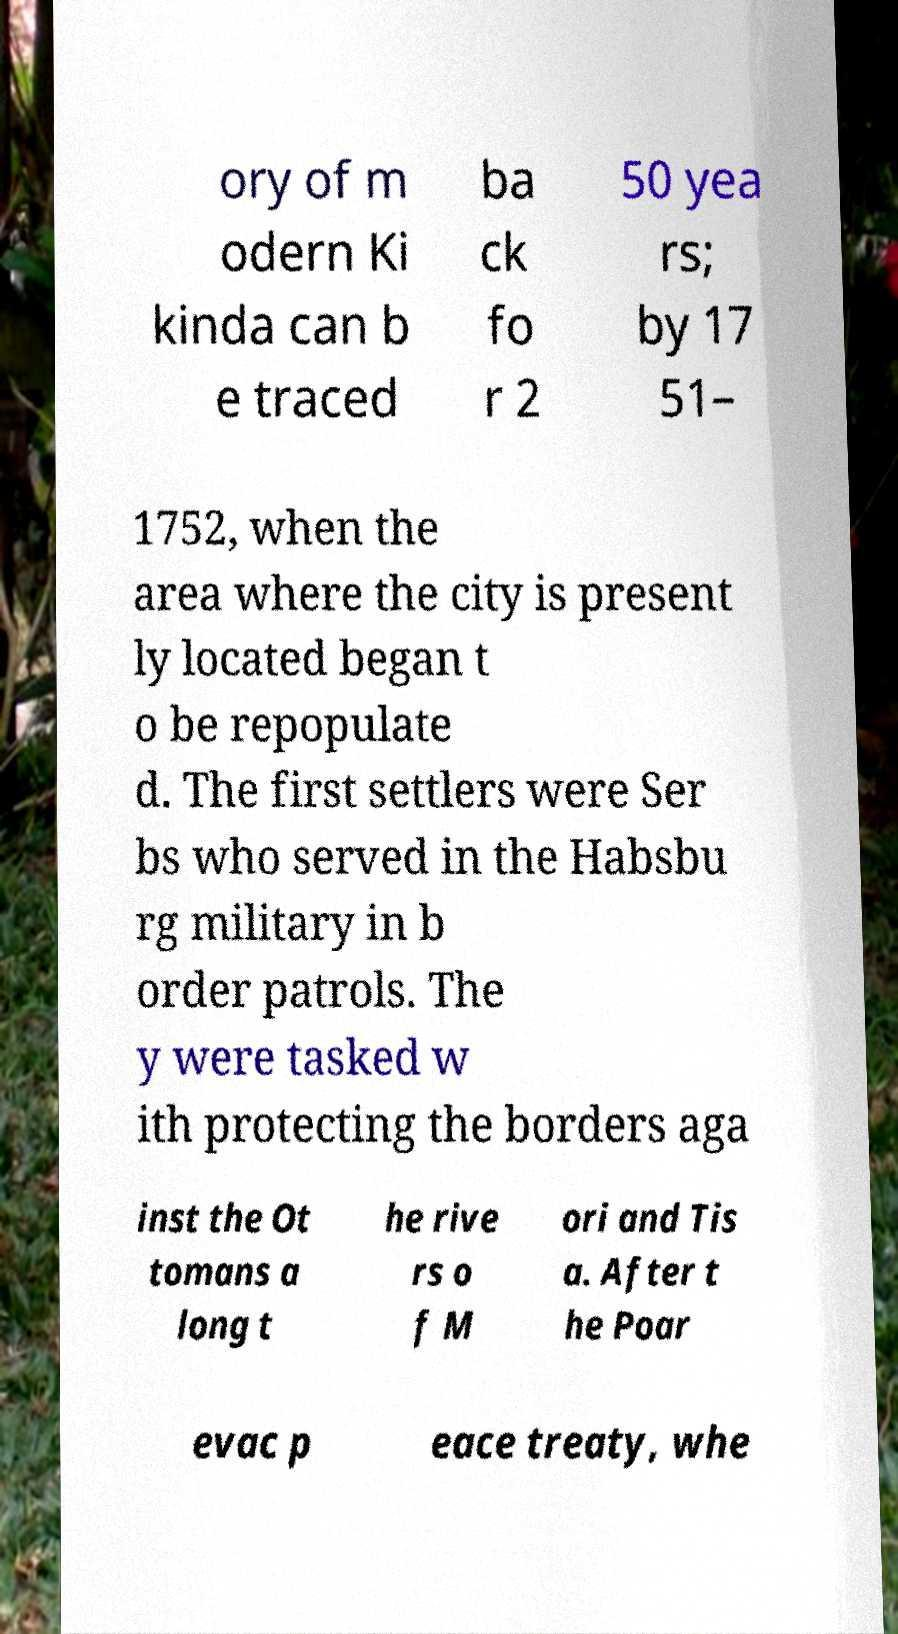There's text embedded in this image that I need extracted. Can you transcribe it verbatim? ory of m odern Ki kinda can b e traced ba ck fo r 2 50 yea rs; by 17 51– 1752, when the area where the city is present ly located began t o be repopulate d. The first settlers were Ser bs who served in the Habsbu rg military in b order patrols. The y were tasked w ith protecting the borders aga inst the Ot tomans a long t he rive rs o f M ori and Tis a. After t he Poar evac p eace treaty, whe 